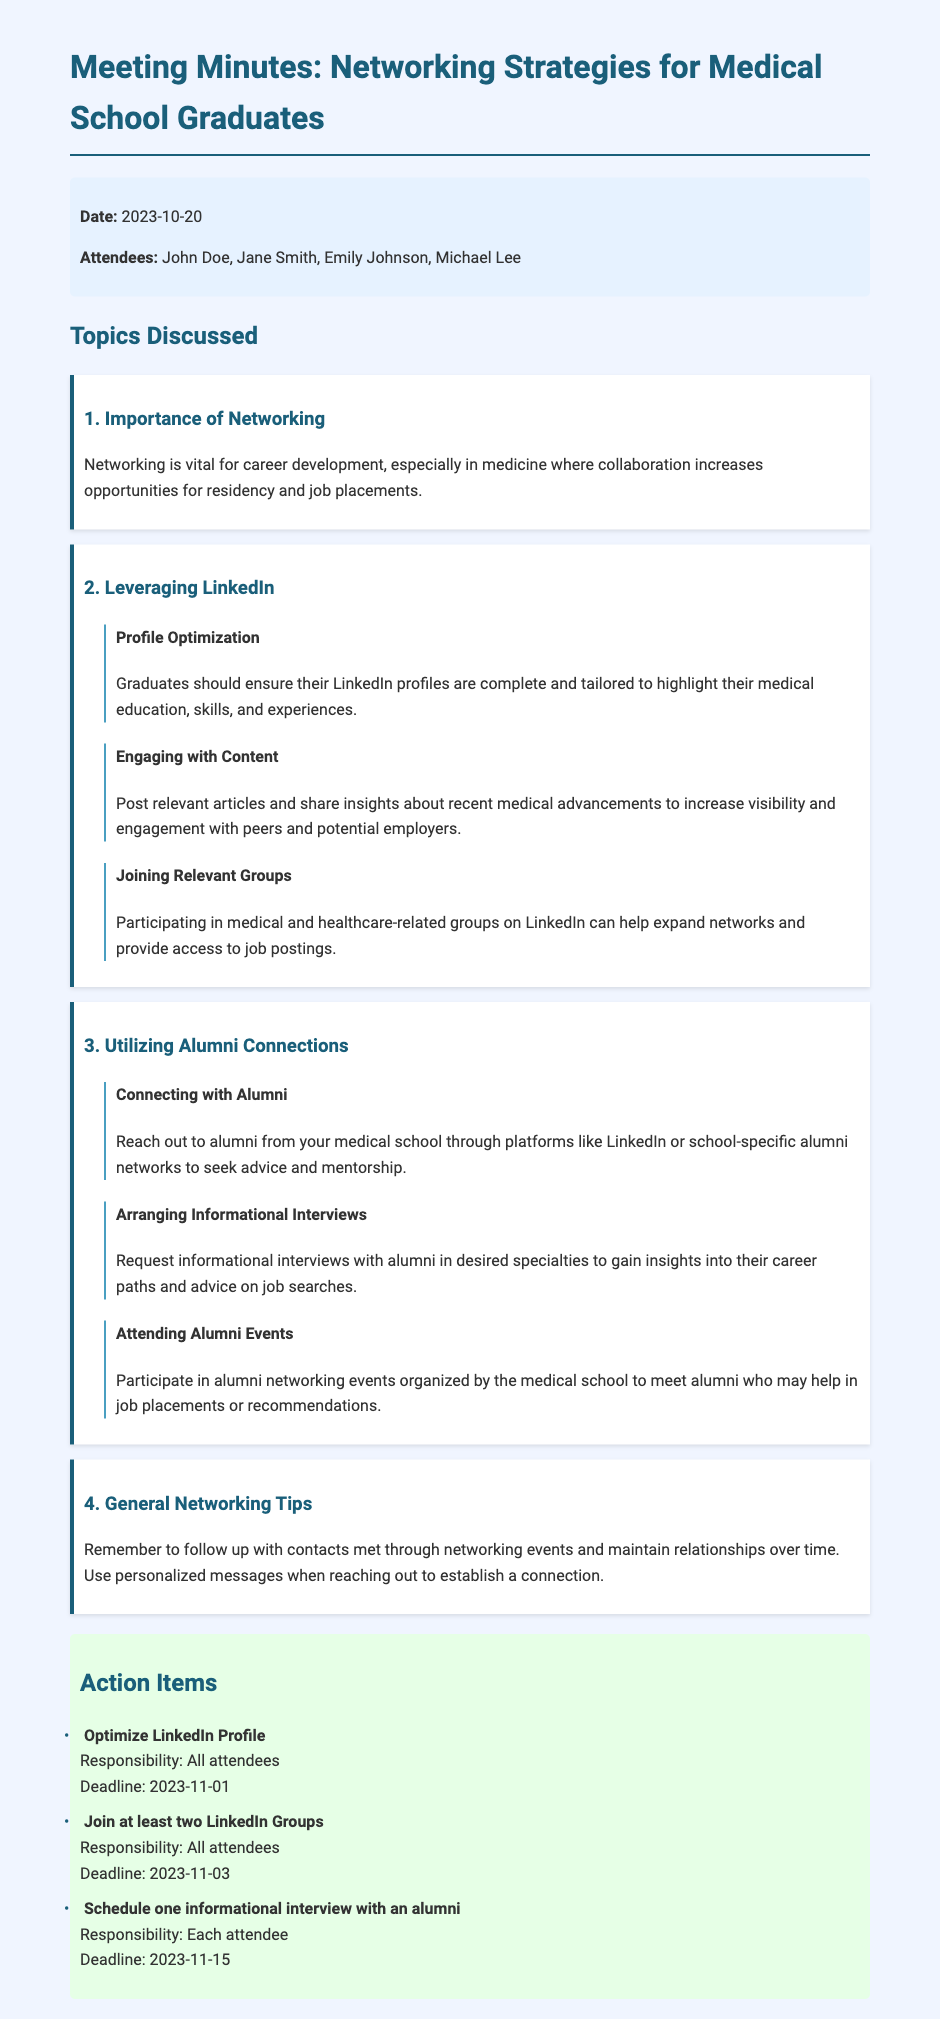What was the date of the meeting? The meeting date is specifically mentioned in the meta-info section of the document.
Answer: 2023-10-20 Who are two attendees present at the meeting? The attendees are listed in the meta-info section, and anyone can be named from that list.
Answer: John Doe, Jane Smith What is one recommended action for all attendees by the deadline? The action items section specifies what all attendees need to do before the respective deadlines.
Answer: Optimize LinkedIn Profile Which platform is suggested for connecting with alumni? The document highlights specific platforms for reaching out to alumni in the section on utilizing alumni connections.
Answer: LinkedIn What networking strategy involves sharing relevant articles? This strategy is mentioned in the section about leveraging LinkedIn, showcasing engagement with content.
Answer: Engaging with Content How many informational interviews should each attendee schedule? The number is specified in the action items section regarding the responsibilities of each attendee.
Answer: One What is the purpose of attending alumni events? This information is found in the section discussing alumni connections, explaining the benefits of attending such events.
Answer: Networking What is emphasized about following up with contacts? The document provides advice on maintaining relationships over time in the general networking tips section.
Answer: Follow up 